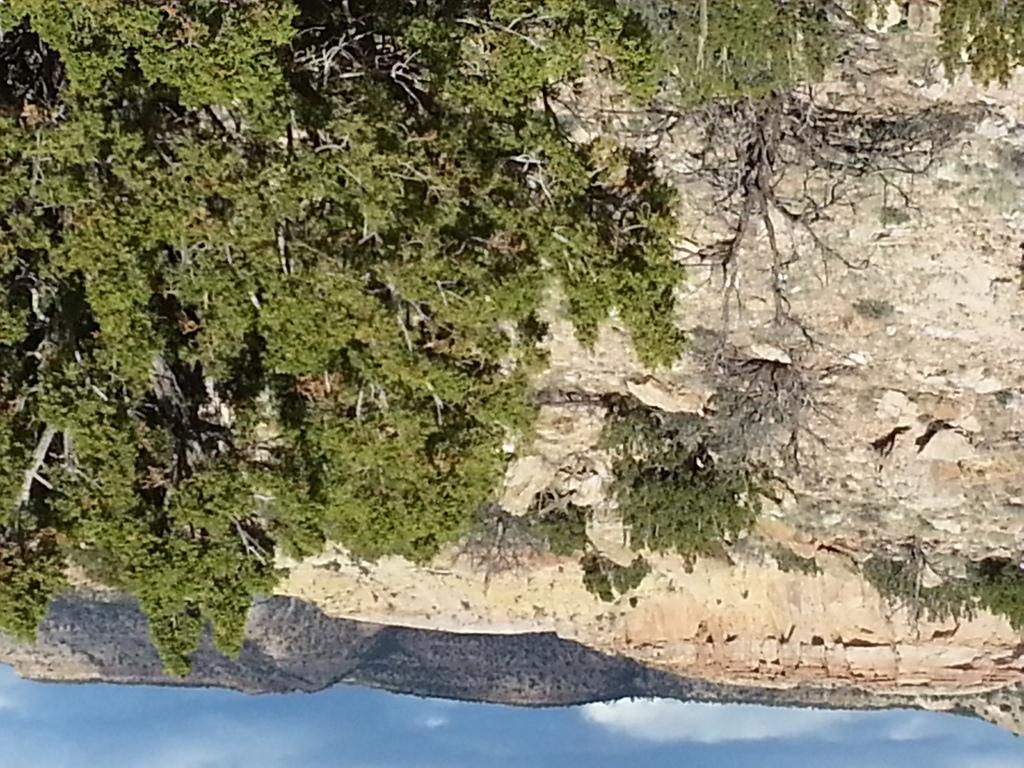What type of natural landform can be seen in the image? There are mountains in the image. What type of vegetation is present in the image? There are trees in the image. What is the condition of the sky in the image? The sky is clear in the image. Where is the jail located in the image? There is no jail present in the image. Can you see a tramp walking through the alley in the image? There is no alley or tramp present in the image. 